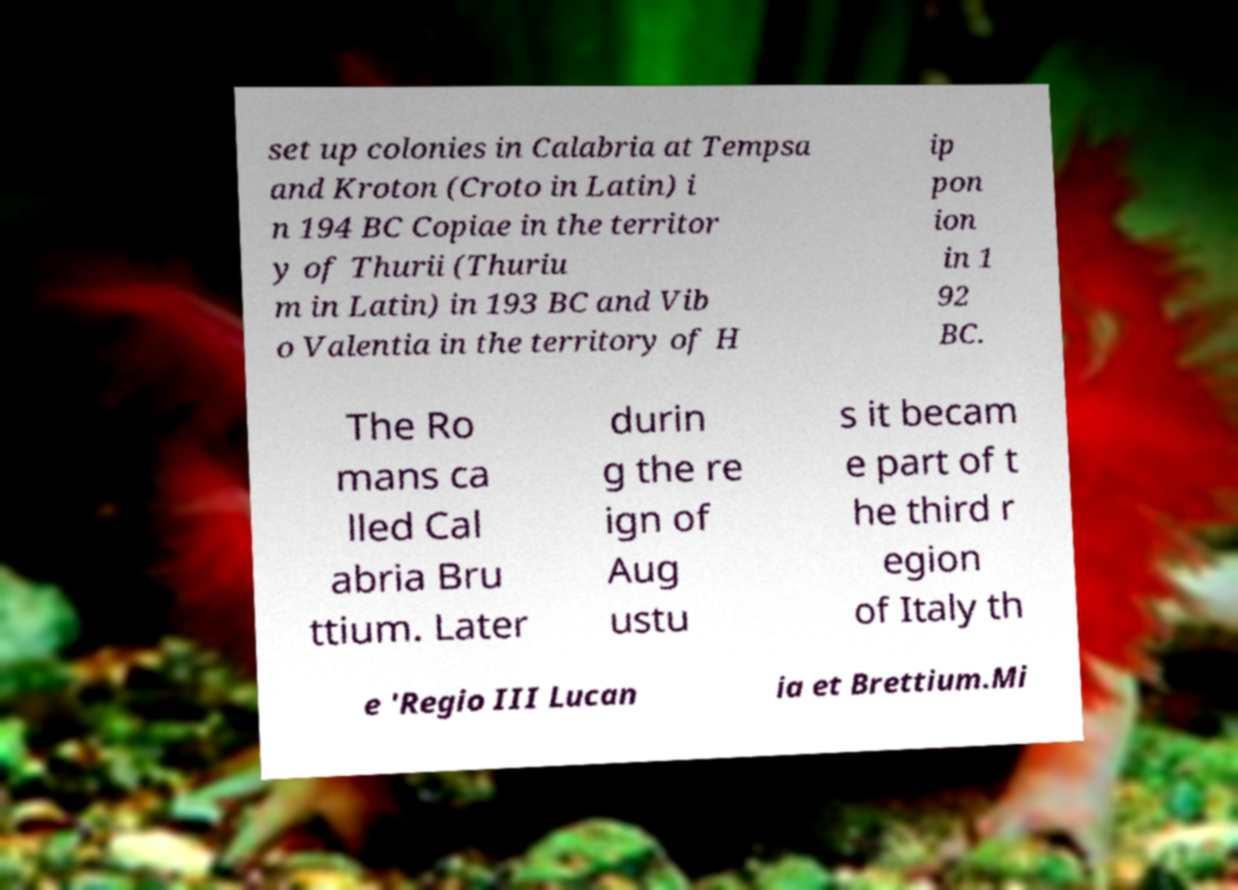Please identify and transcribe the text found in this image. set up colonies in Calabria at Tempsa and Kroton (Croto in Latin) i n 194 BC Copiae in the territor y of Thurii (Thuriu m in Latin) in 193 BC and Vib o Valentia in the territory of H ip pon ion in 1 92 BC. The Ro mans ca lled Cal abria Bru ttium. Later durin g the re ign of Aug ustu s it becam e part of t he third r egion of Italy th e 'Regio III Lucan ia et Brettium.Mi 